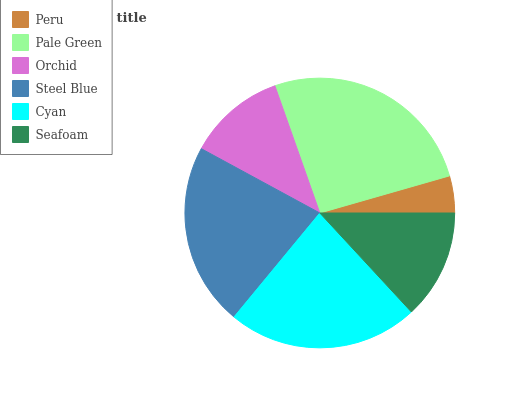Is Peru the minimum?
Answer yes or no. Yes. Is Pale Green the maximum?
Answer yes or no. Yes. Is Orchid the minimum?
Answer yes or no. No. Is Orchid the maximum?
Answer yes or no. No. Is Pale Green greater than Orchid?
Answer yes or no. Yes. Is Orchid less than Pale Green?
Answer yes or no. Yes. Is Orchid greater than Pale Green?
Answer yes or no. No. Is Pale Green less than Orchid?
Answer yes or no. No. Is Steel Blue the high median?
Answer yes or no. Yes. Is Seafoam the low median?
Answer yes or no. Yes. Is Peru the high median?
Answer yes or no. No. Is Steel Blue the low median?
Answer yes or no. No. 